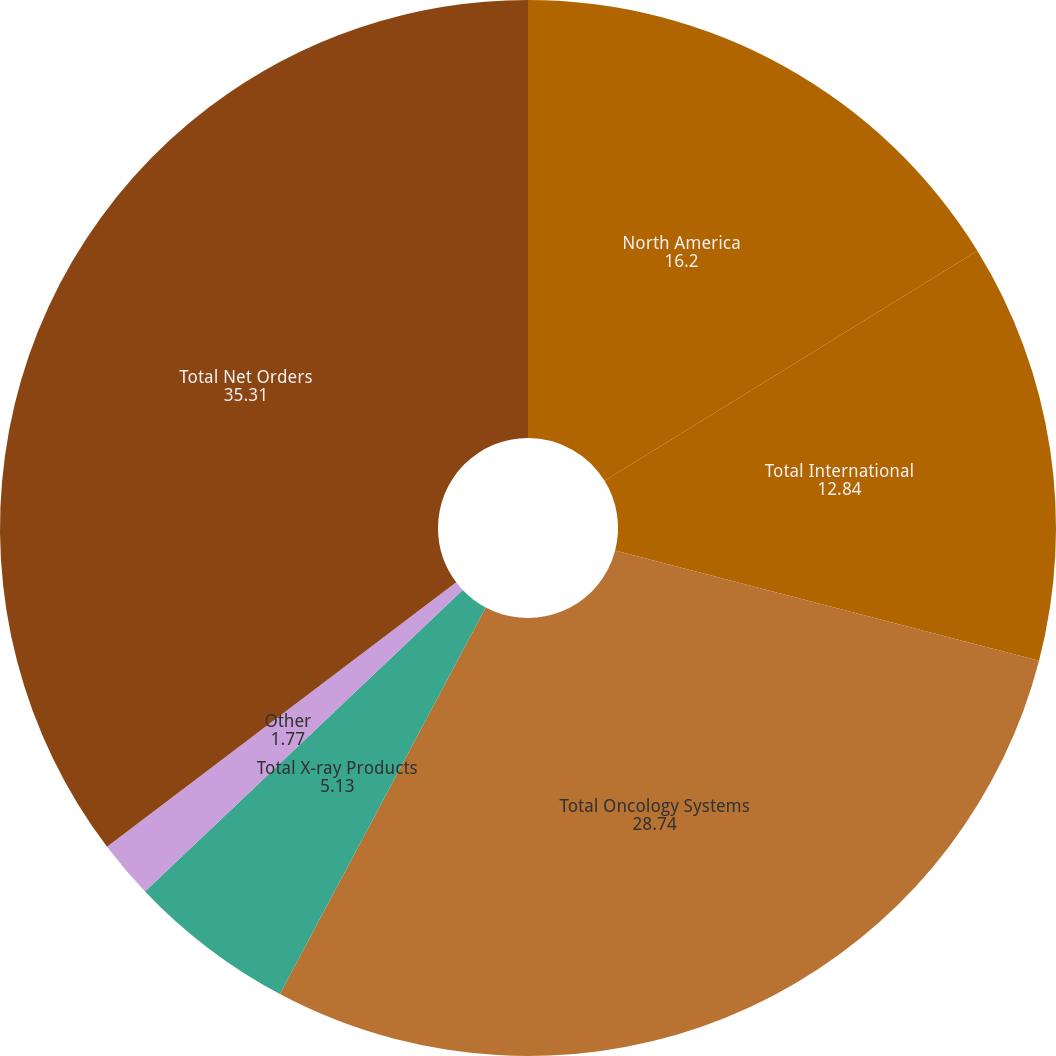<chart> <loc_0><loc_0><loc_500><loc_500><pie_chart><fcel>North America<fcel>Total International<fcel>Total Oncology Systems<fcel>Total X-ray Products<fcel>Other<fcel>Total Net Orders<nl><fcel>16.2%<fcel>12.84%<fcel>28.74%<fcel>5.13%<fcel>1.77%<fcel>35.31%<nl></chart> 